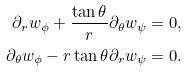Convert formula to latex. <formula><loc_0><loc_0><loc_500><loc_500>\partial _ { r } w _ { \phi } + \frac { \tan \theta } { r } \partial _ { \theta } w _ { \psi } & = 0 , \\ \partial _ { \theta } w _ { \phi } - r \tan \theta \partial _ { r } w _ { \psi } & = 0 .</formula> 